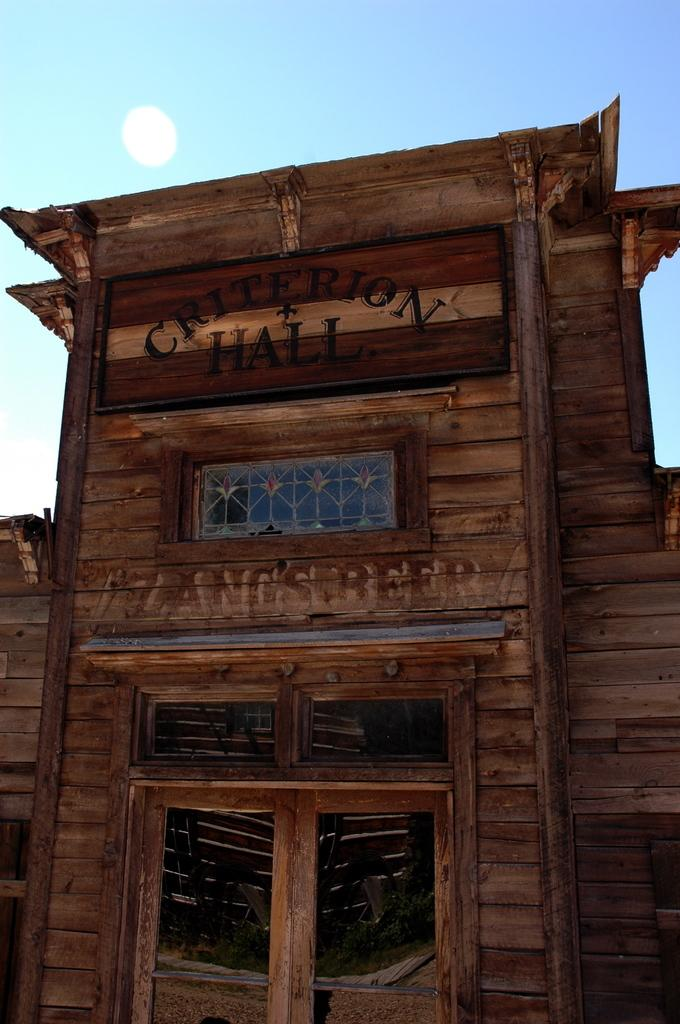What is the main subject of the image? The main subject of the image is a building. Can you describe the building in the image? The building is located in the center of the image. Is there any text visible on the building? Yes, there is text written on the building. What is the queen's reaction to the society's response in the image? There is no queen, reaction, or society present in the image; it only features a building with text on it. 